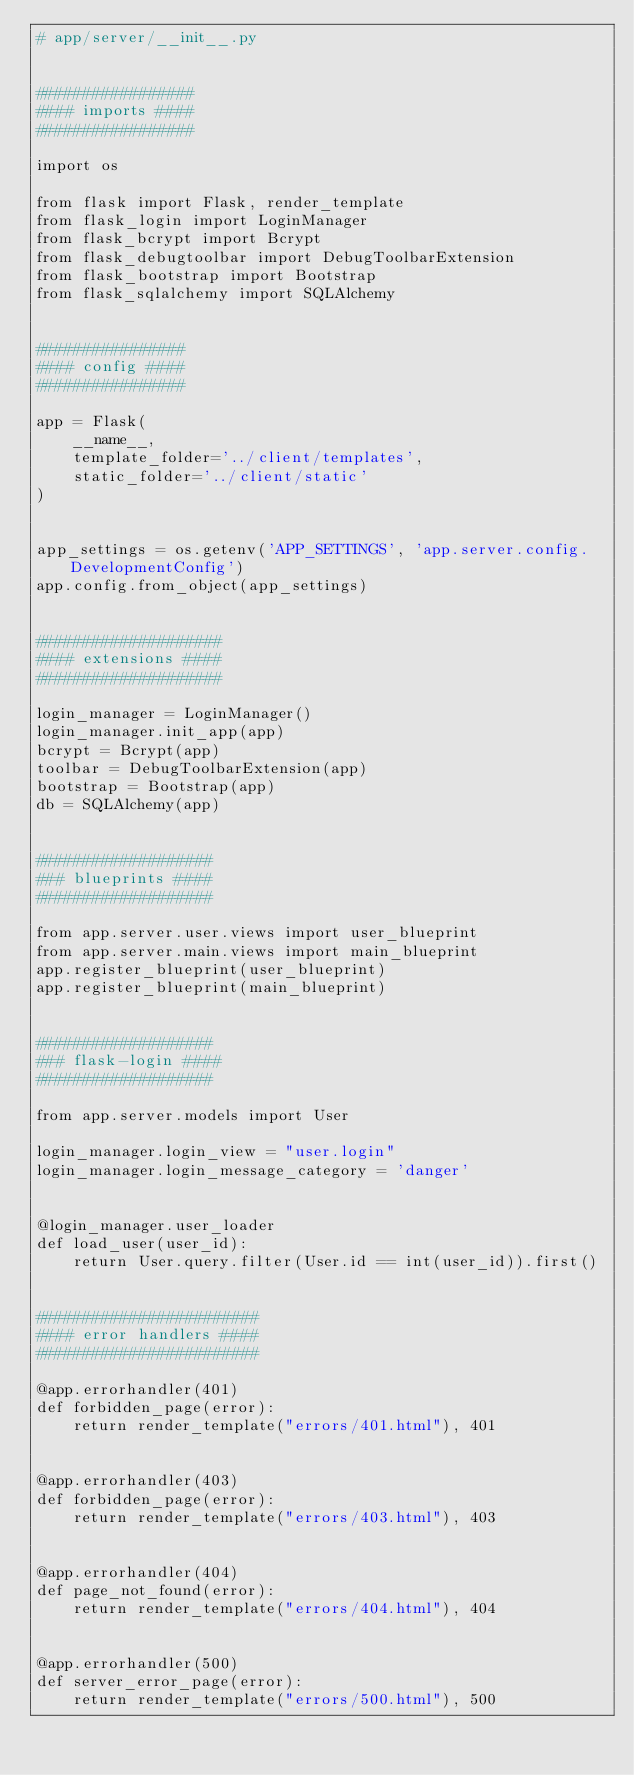<code> <loc_0><loc_0><loc_500><loc_500><_Python_># app/server/__init__.py


#################
#### imports ####
#################

import os

from flask import Flask, render_template
from flask_login import LoginManager
from flask_bcrypt import Bcrypt
from flask_debugtoolbar import DebugToolbarExtension
from flask_bootstrap import Bootstrap
from flask_sqlalchemy import SQLAlchemy


################
#### config ####
################

app = Flask(
    __name__,
    template_folder='../client/templates',
    static_folder='../client/static'
)


app_settings = os.getenv('APP_SETTINGS', 'app.server.config.DevelopmentConfig')
app.config.from_object(app_settings)


####################
#### extensions ####
####################

login_manager = LoginManager()
login_manager.init_app(app)
bcrypt = Bcrypt(app)
toolbar = DebugToolbarExtension(app)
bootstrap = Bootstrap(app)
db = SQLAlchemy(app)


###################
### blueprints ####
###################

from app.server.user.views import user_blueprint
from app.server.main.views import main_blueprint
app.register_blueprint(user_blueprint)
app.register_blueprint(main_blueprint)


###################
### flask-login ####
###################

from app.server.models import User

login_manager.login_view = "user.login"
login_manager.login_message_category = 'danger'


@login_manager.user_loader
def load_user(user_id):
    return User.query.filter(User.id == int(user_id)).first()


########################
#### error handlers ####
########################

@app.errorhandler(401)
def forbidden_page(error):
    return render_template("errors/401.html"), 401


@app.errorhandler(403)
def forbidden_page(error):
    return render_template("errors/403.html"), 403


@app.errorhandler(404)
def page_not_found(error):
    return render_template("errors/404.html"), 404


@app.errorhandler(500)
def server_error_page(error):
    return render_template("errors/500.html"), 500
</code> 